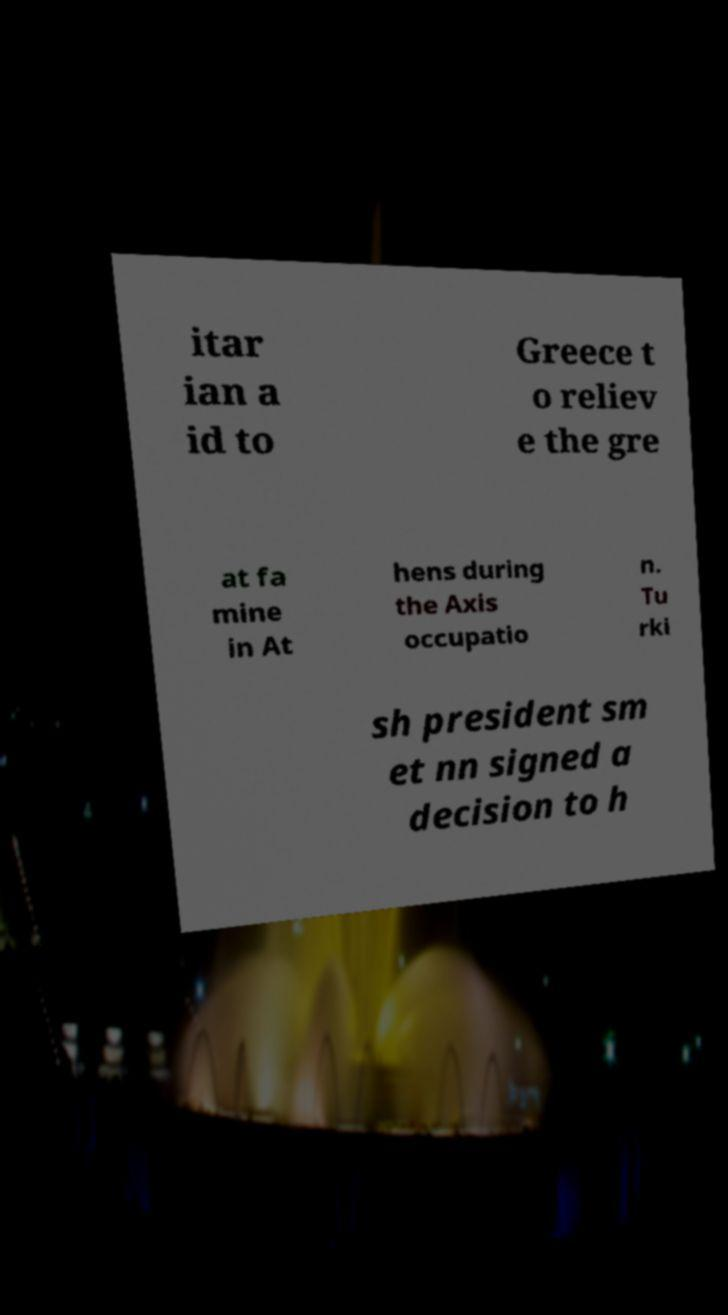Could you extract and type out the text from this image? itar ian a id to Greece t o reliev e the gre at fa mine in At hens during the Axis occupatio n. Tu rki sh president sm et nn signed a decision to h 